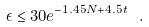Convert formula to latex. <formula><loc_0><loc_0><loc_500><loc_500>\epsilon \leq 3 0 e ^ { - 1 . 4 5 N + 4 . 5 t } \ .</formula> 